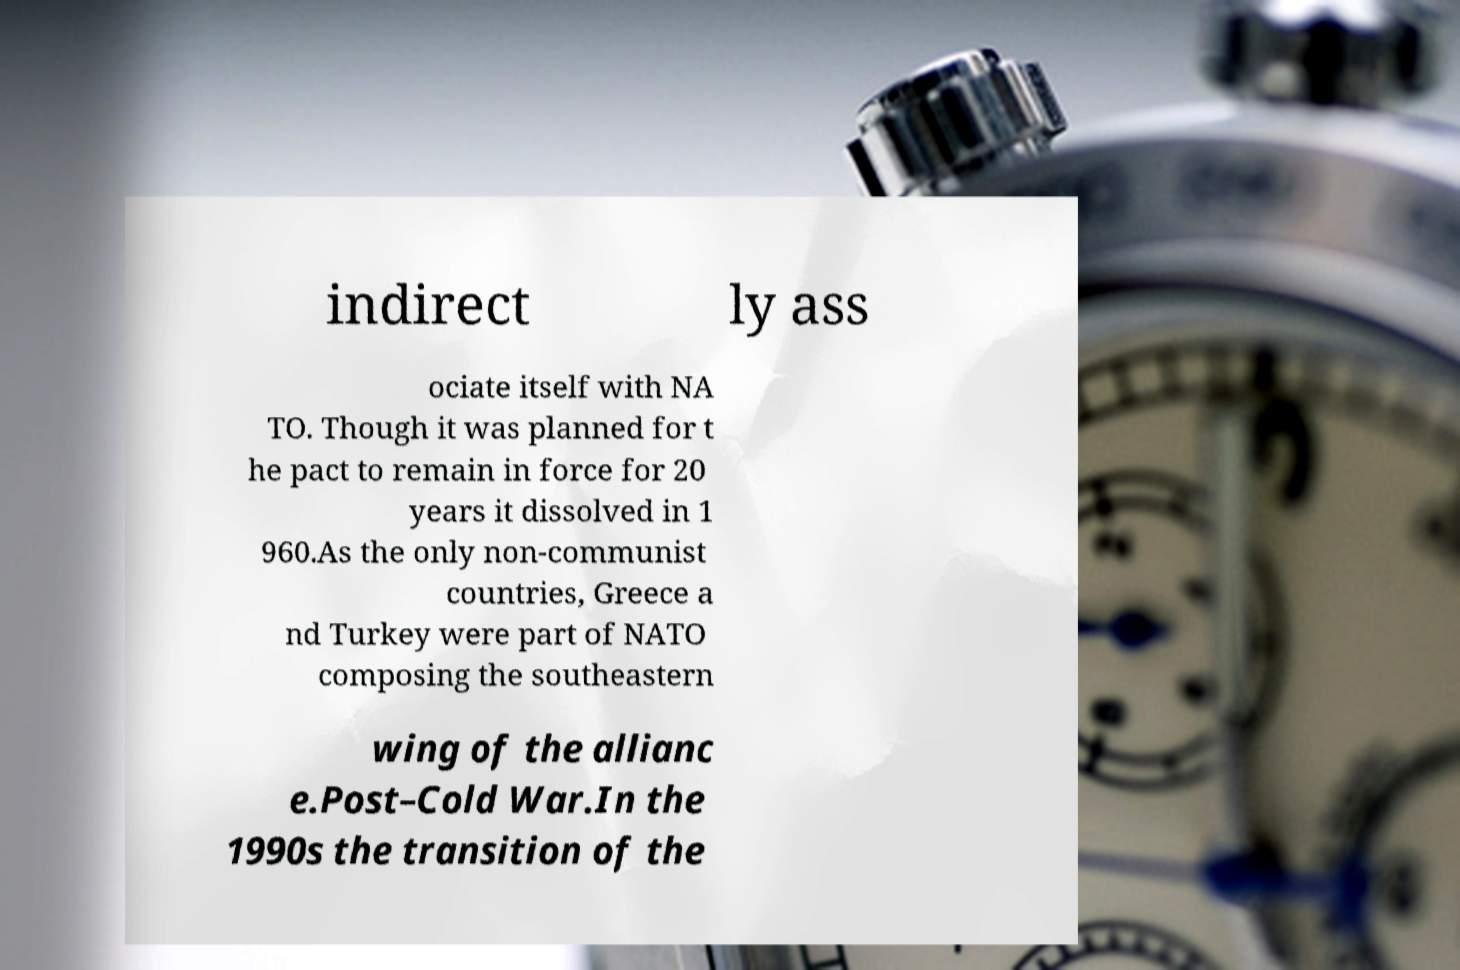For documentation purposes, I need the text within this image transcribed. Could you provide that? indirect ly ass ociate itself with NA TO. Though it was planned for t he pact to remain in force for 20 years it dissolved in 1 960.As the only non-communist countries, Greece a nd Turkey were part of NATO composing the southeastern wing of the allianc e.Post–Cold War.In the 1990s the transition of the 